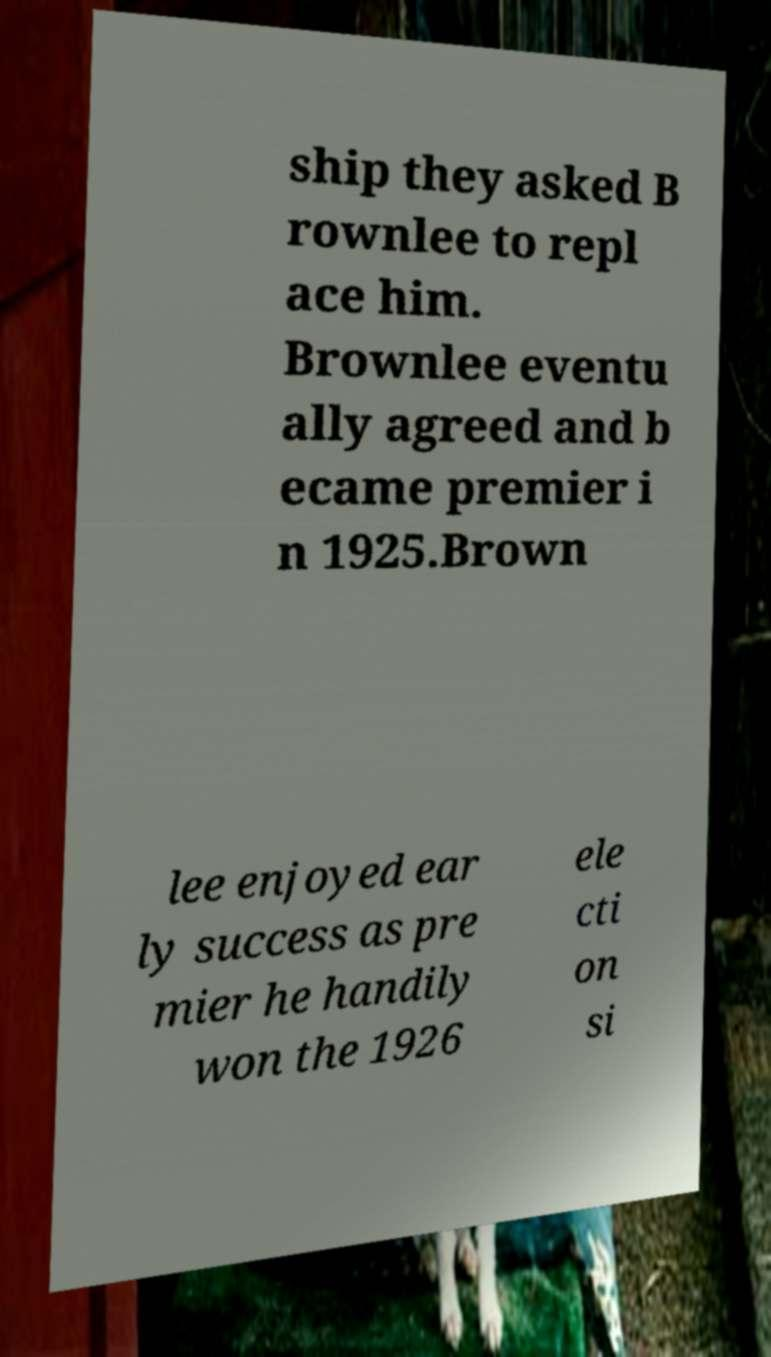Please read and relay the text visible in this image. What does it say? ship they asked B rownlee to repl ace him. Brownlee eventu ally agreed and b ecame premier i n 1925.Brown lee enjoyed ear ly success as pre mier he handily won the 1926 ele cti on si 